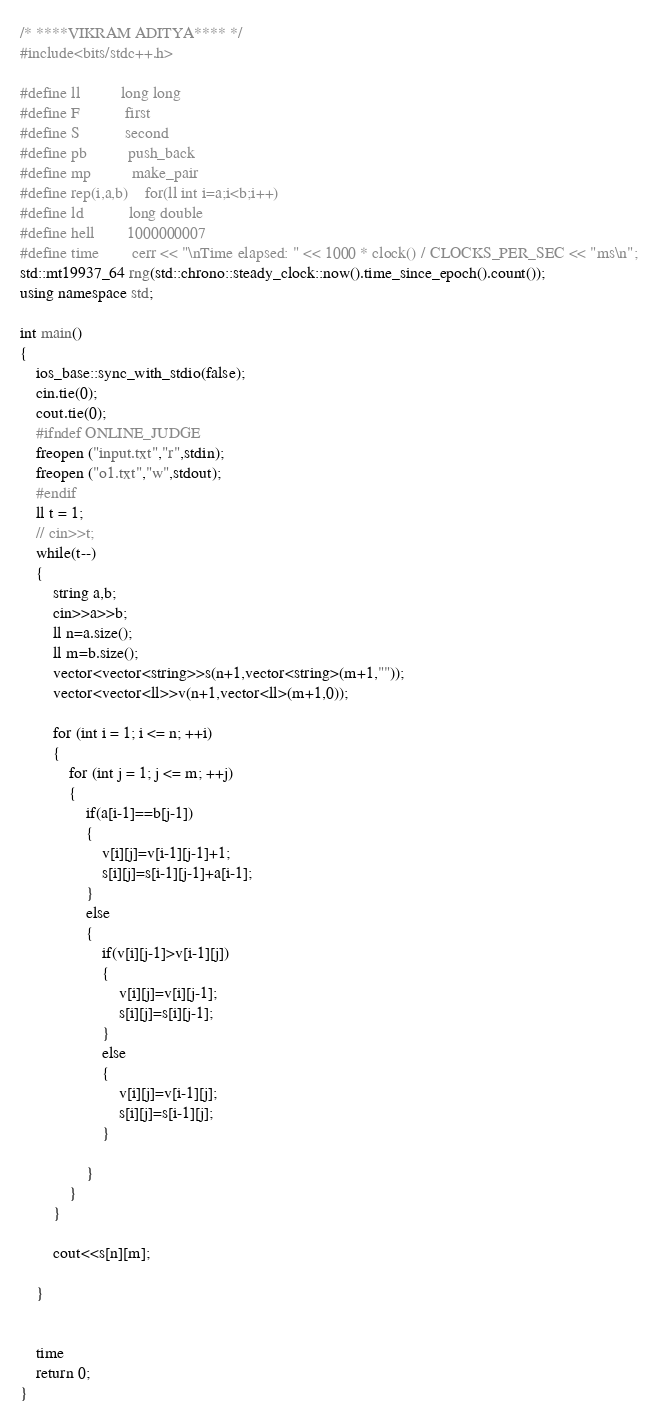Convert code to text. <code><loc_0><loc_0><loc_500><loc_500><_C++_>/* ****VIKRAM ADITYA**** */
#include<bits/stdc++.h>

#define ll          long long
#define F           first
#define S           second
#define pb          push_back
#define mp          make_pair
#define rep(i,a,b)    for(ll int i=a;i<b;i++)
#define ld 			long double
#define hell        1000000007
#define time        cerr << "\nTime elapsed: " << 1000 * clock() / CLOCKS_PER_SEC << "ms\n";
std::mt19937_64 rng(std::chrono::steady_clock::now().time_since_epoch().count());
using namespace std;

int main()
{
	ios_base::sync_with_stdio(false);
	cin.tie(0);
	cout.tie(0);
	#ifndef ONLINE_JUDGE
	freopen ("input.txt","r",stdin);
	freopen ("o1.txt","w",stdout);
	#endif
	ll t = 1;
	// cin>>t;
	while(t--)
	{
		string a,b;
		cin>>a>>b;
		ll n=a.size();
		ll m=b.size();
		vector<vector<string>>s(n+1,vector<string>(m+1,""));
		vector<vector<ll>>v(n+1,vector<ll>(m+1,0));

		for (int i = 1; i <= n; ++i)
		{
			for (int j = 1; j <= m; ++j)
			{
				if(a[i-1]==b[j-1])
				{
					v[i][j]=v[i-1][j-1]+1;
					s[i][j]=s[i-1][j-1]+a[i-1];
				}
				else
				{
					if(v[i][j-1]>v[i-1][j])
					{
						v[i][j]=v[i][j-1];
						s[i][j]=s[i][j-1];
					}
					else
					{
						v[i][j]=v[i-1][j];
						s[i][j]=s[i-1][j];
					}

				}
			}
		}

		cout<<s[n][m];
		
	}

	
	time
	return 0;
}</code> 